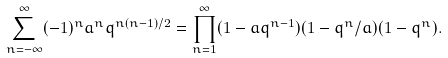<formula> <loc_0><loc_0><loc_500><loc_500>\sum _ { n = - \infty } ^ { \infty } ( - 1 ) ^ { n } a ^ { n } q ^ { n ( n - 1 ) / 2 } = \prod _ { n = 1 } ^ { \infty } ( 1 - a q ^ { n - 1 } ) ( 1 - q ^ { n } / a ) ( 1 - q ^ { n } ) .</formula> 